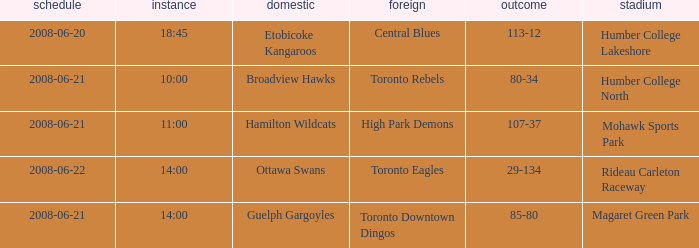What is the Away with a Ground that is humber college lakeshore? Central Blues. 